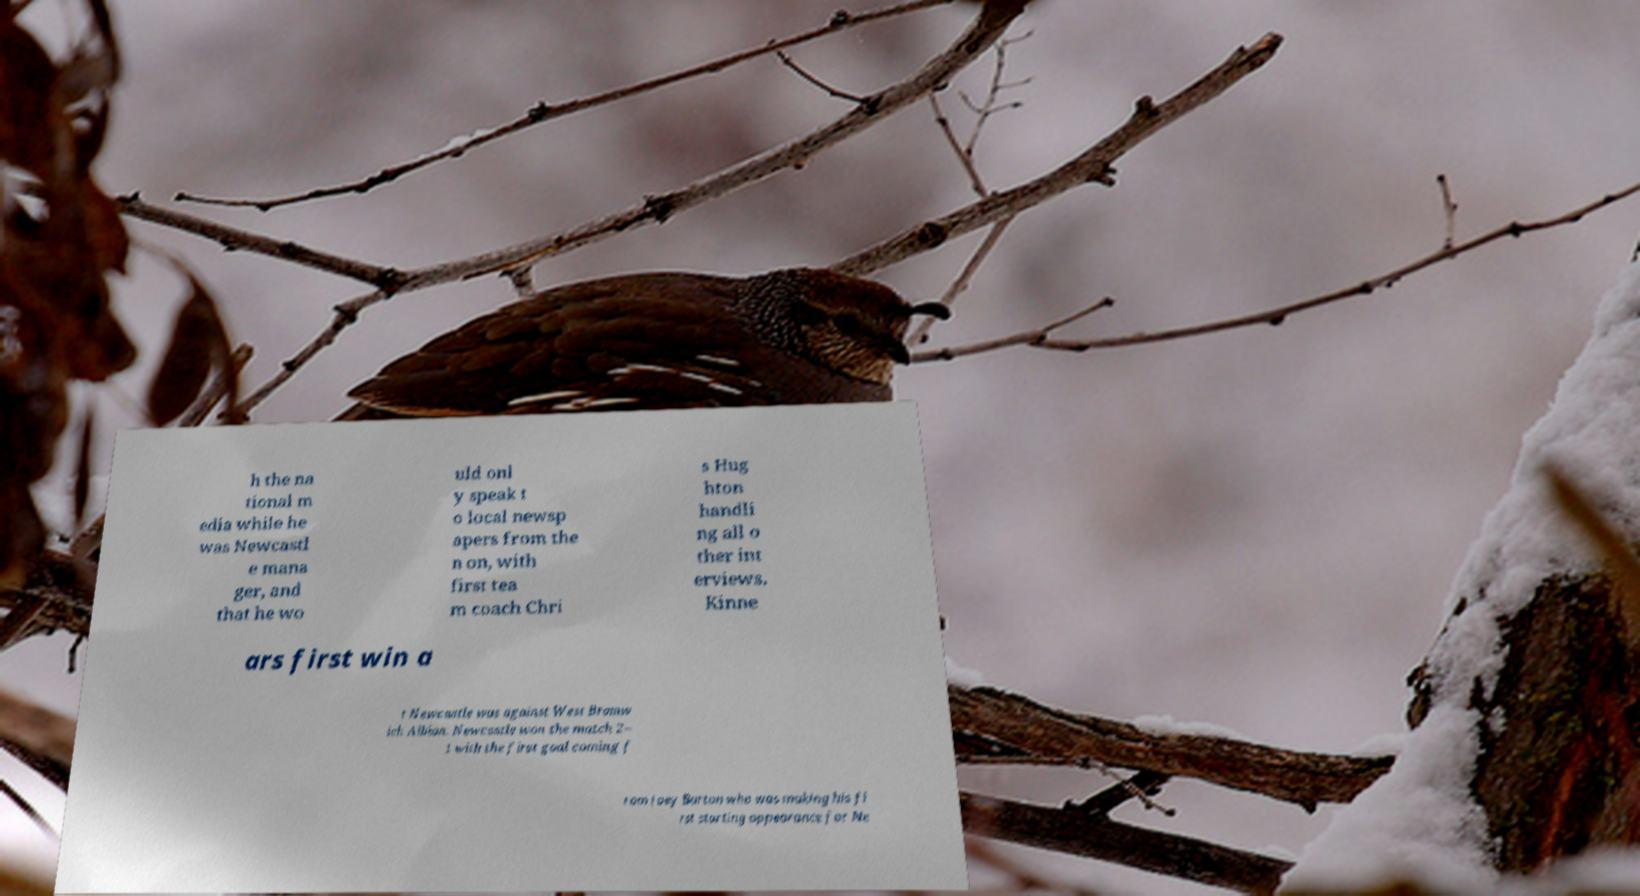Can you read and provide the text displayed in the image?This photo seems to have some interesting text. Can you extract and type it out for me? h the na tional m edia while he was Newcastl e mana ger, and that he wo uld onl y speak t o local newsp apers from the n on, with first tea m coach Chri s Hug hton handli ng all o ther int erviews. Kinne ars first win a t Newcastle was against West Bromw ich Albion. Newcastle won the match 2– 1 with the first goal coming f rom Joey Barton who was making his fi rst starting appearance for Ne 